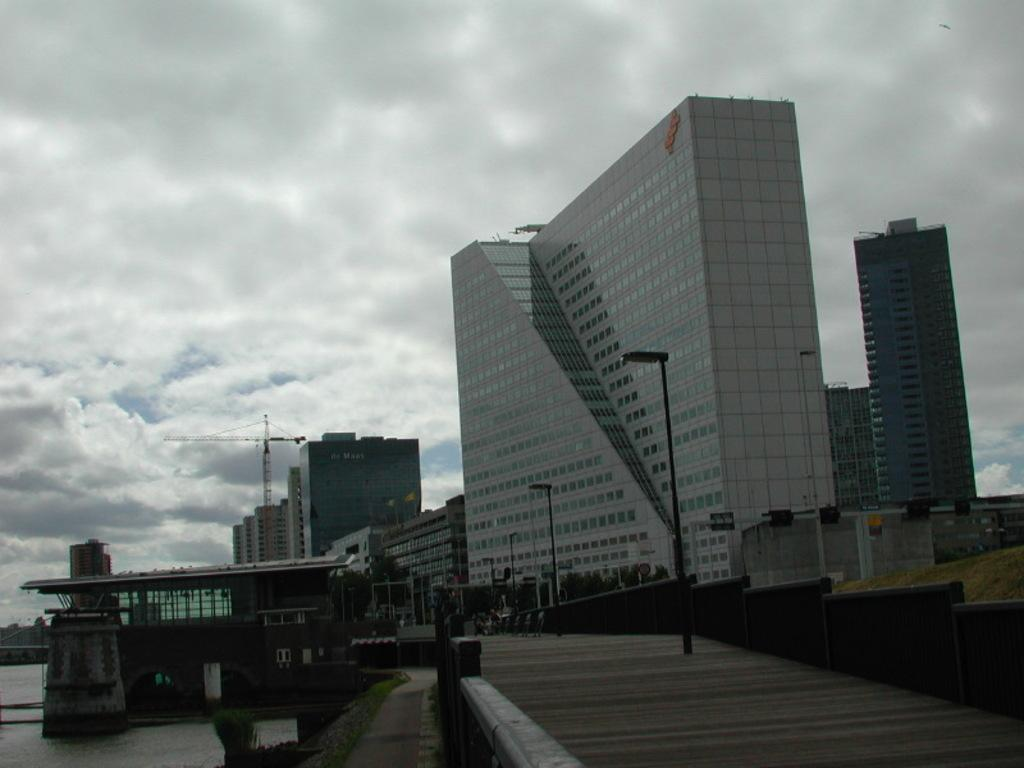What type of structures can be seen in the image? There are buildings in the image. What other objects are present in the image? There are poles, street lights, and construction cranes in the image. What can be seen on the ground in the image? The ground is visible in the image. What else is visible in the image besides the ground? There is water and the sky visible in the image. What is the condition of the sky in the image? Clouds are present in the sky. Can you tell me the punchline of the joke in the image? There is no joke present in the image. What type of agreement is being signed by the people in the image? There are no people or agreements present in the image. 